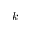Convert formula to latex. <formula><loc_0><loc_0><loc_500><loc_500>k</formula> 